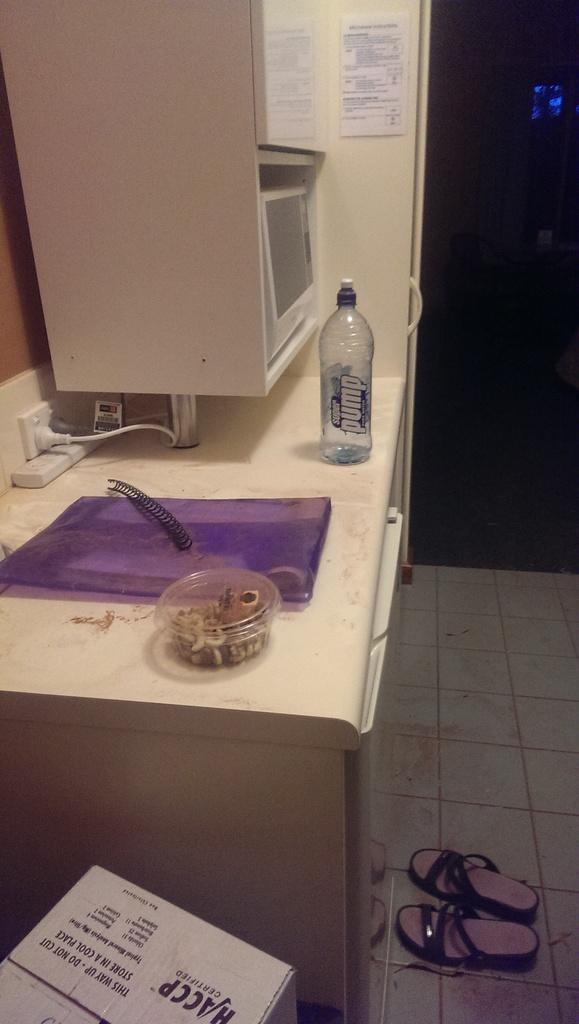What is one word on the box?
Provide a short and direct response. This. 